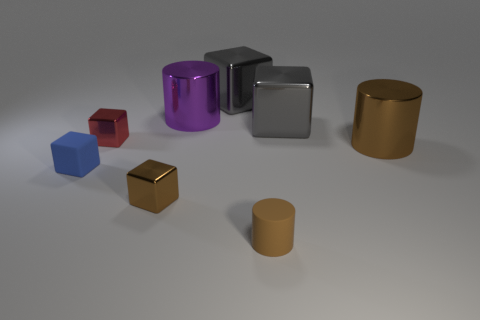Can you tell if the lighting in the scene comes from multiple sources? The lighting in the scene appears to come from a single source, as indicated by the uniform shadows cast by each object on the surface.  Do these objects cast different lengths of shadows? Yes, the objects cast shadows of different lengths, which could indicate differences in their sizes and heights relative to the light source. 